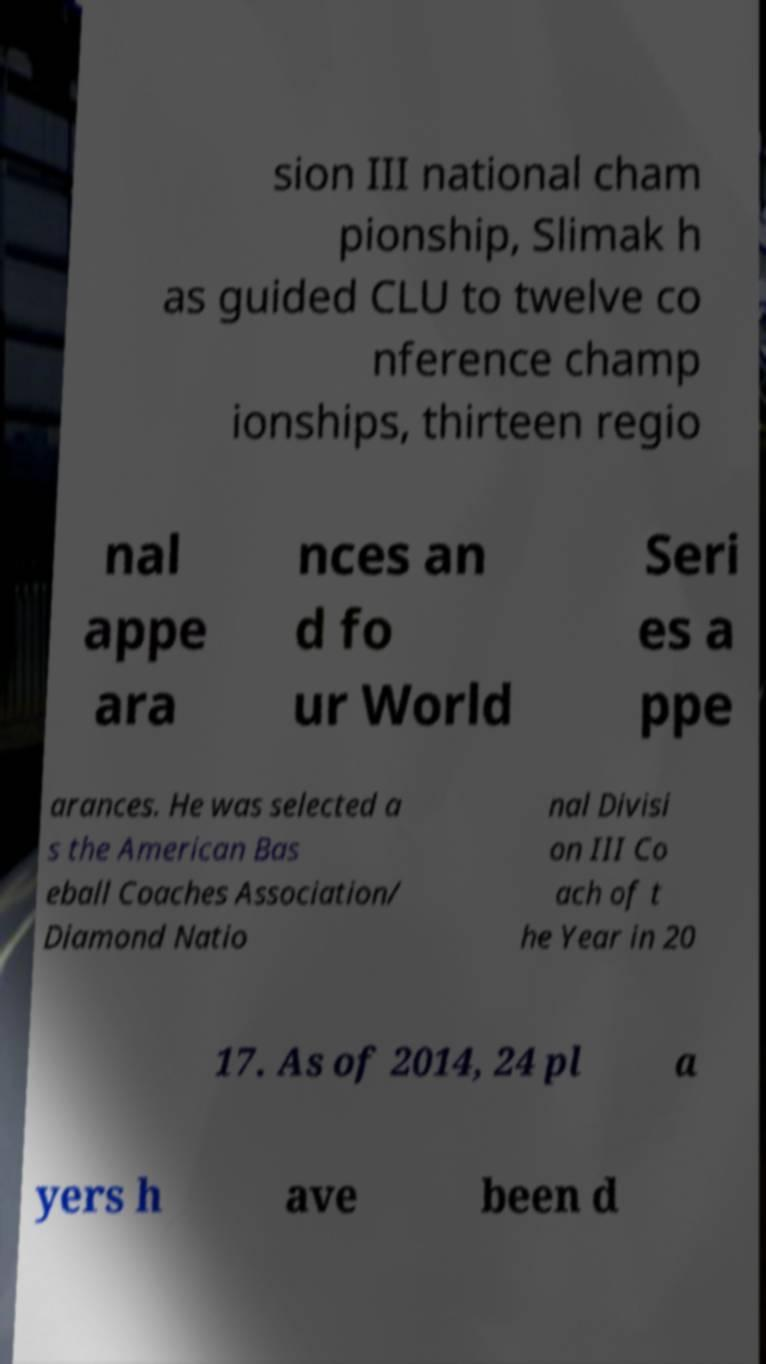Please identify and transcribe the text found in this image. sion III national cham pionship, Slimak h as guided CLU to twelve co nference champ ionships, thirteen regio nal appe ara nces an d fo ur World Seri es a ppe arances. He was selected a s the American Bas eball Coaches Association/ Diamond Natio nal Divisi on III Co ach of t he Year in 20 17. As of 2014, 24 pl a yers h ave been d 